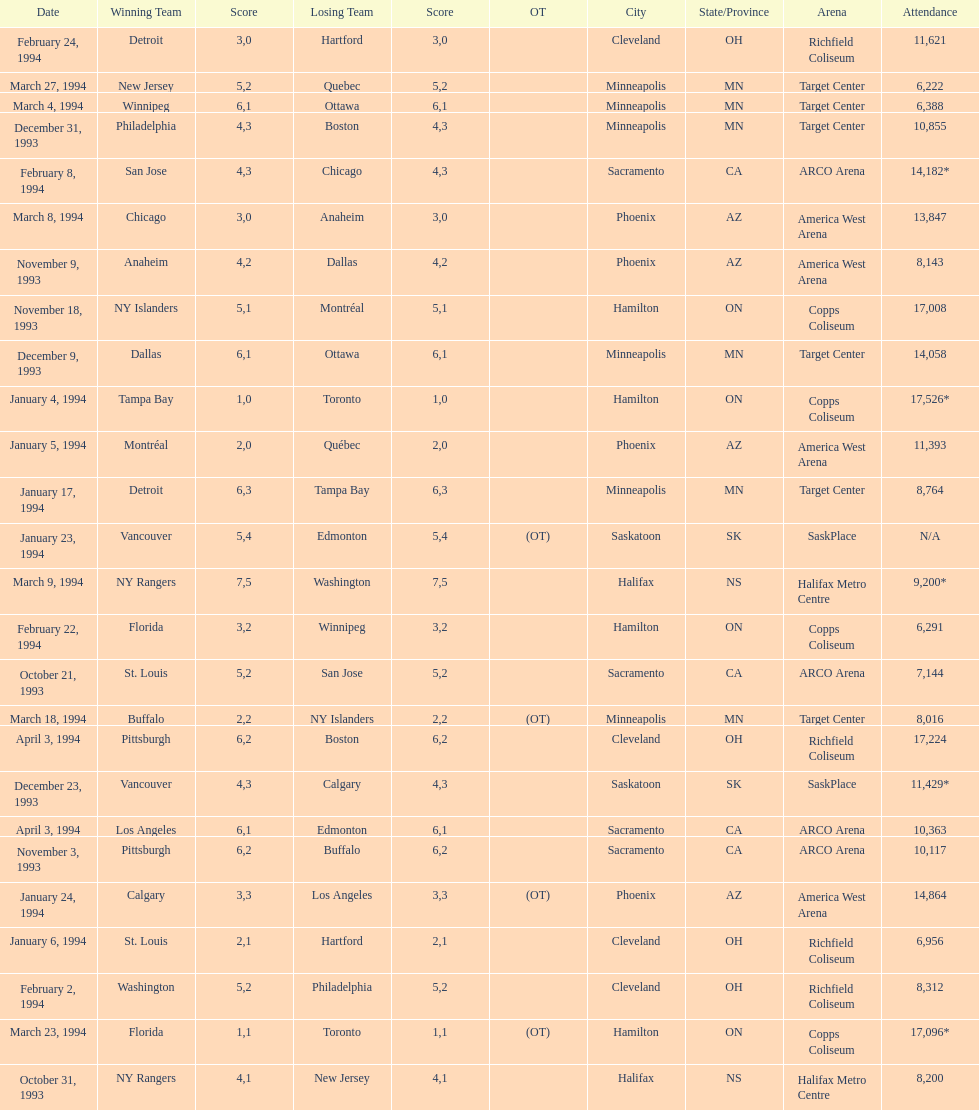Who won the game the day before the january 5, 1994 game? Tampa Bay. 